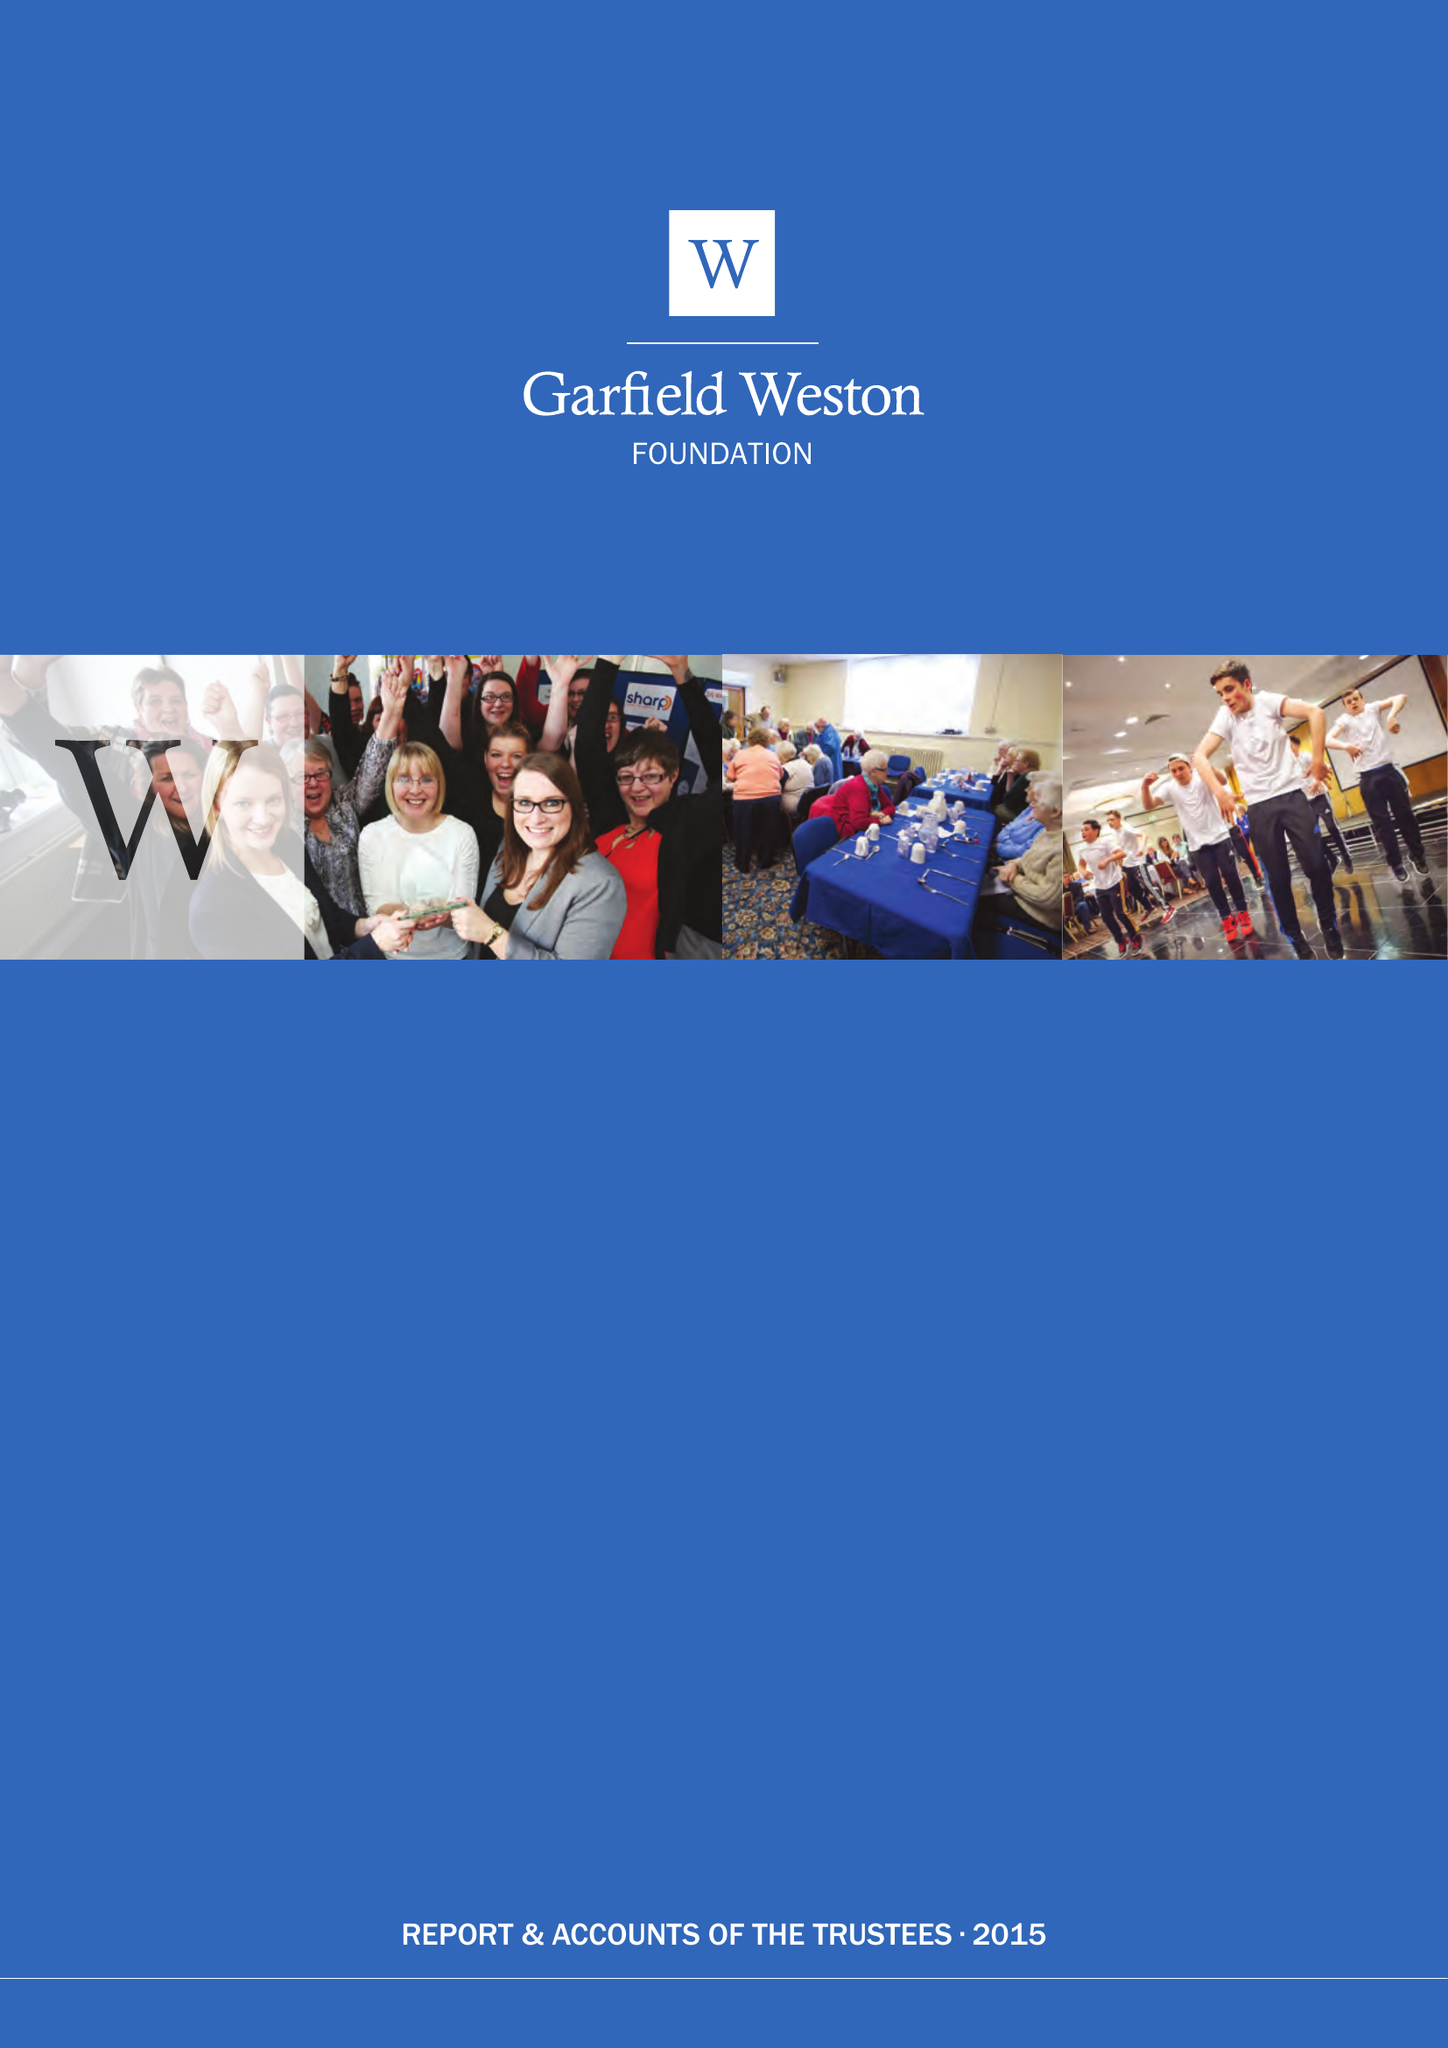What is the value for the address__street_line?
Answer the question using a single word or phrase. 10 GROSVENOR STREET 